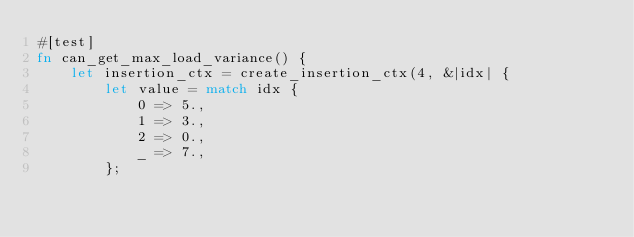<code> <loc_0><loc_0><loc_500><loc_500><_Rust_>#[test]
fn can_get_max_load_variance() {
    let insertion_ctx = create_insertion_ctx(4, &|idx| {
        let value = match idx {
            0 => 5.,
            1 => 3.,
            2 => 0.,
            _ => 7.,
        };</code> 